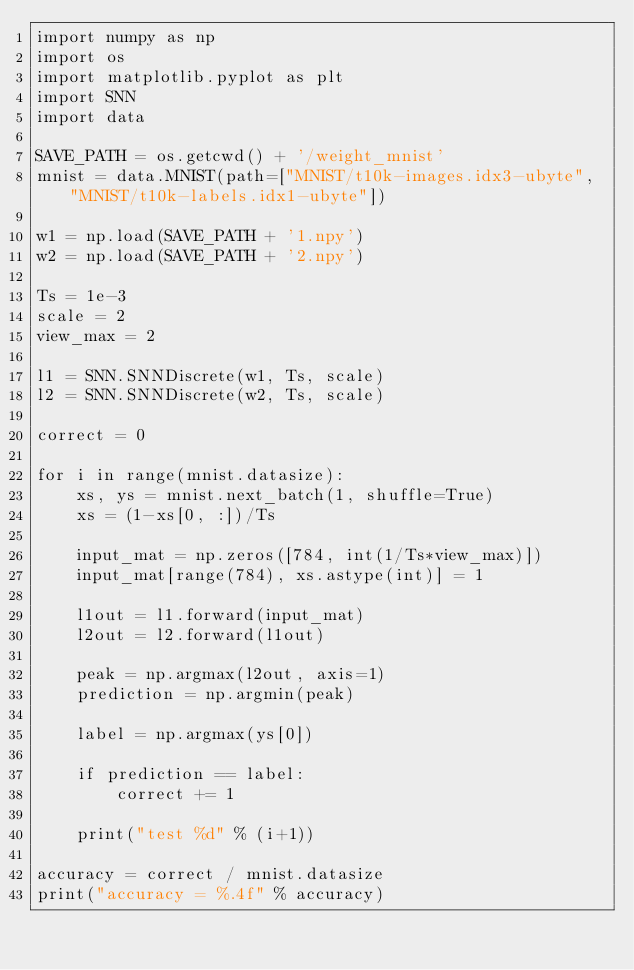Convert code to text. <code><loc_0><loc_0><loc_500><loc_500><_Python_>import numpy as np
import os
import matplotlib.pyplot as plt
import SNN
import data

SAVE_PATH = os.getcwd() + '/weight_mnist'
mnist = data.MNIST(path=["MNIST/t10k-images.idx3-ubyte", "MNIST/t10k-labels.idx1-ubyte"])

w1 = np.load(SAVE_PATH + '1.npy')
w2 = np.load(SAVE_PATH + '2.npy')

Ts = 1e-3
scale = 2
view_max = 2

l1 = SNN.SNNDiscrete(w1, Ts, scale)
l2 = SNN.SNNDiscrete(w2, Ts, scale)

correct = 0

for i in range(mnist.datasize):
    xs, ys = mnist.next_batch(1, shuffle=True)
    xs = (1-xs[0, :])/Ts

    input_mat = np.zeros([784, int(1/Ts*view_max)])
    input_mat[range(784), xs.astype(int)] = 1

    l1out = l1.forward(input_mat)
    l2out = l2.forward(l1out)

    peak = np.argmax(l2out, axis=1)
    prediction = np.argmin(peak)

    label = np.argmax(ys[0])

    if prediction == label:
        correct += 1

    print("test %d" % (i+1))

accuracy = correct / mnist.datasize
print("accuracy = %.4f" % accuracy)
</code> 